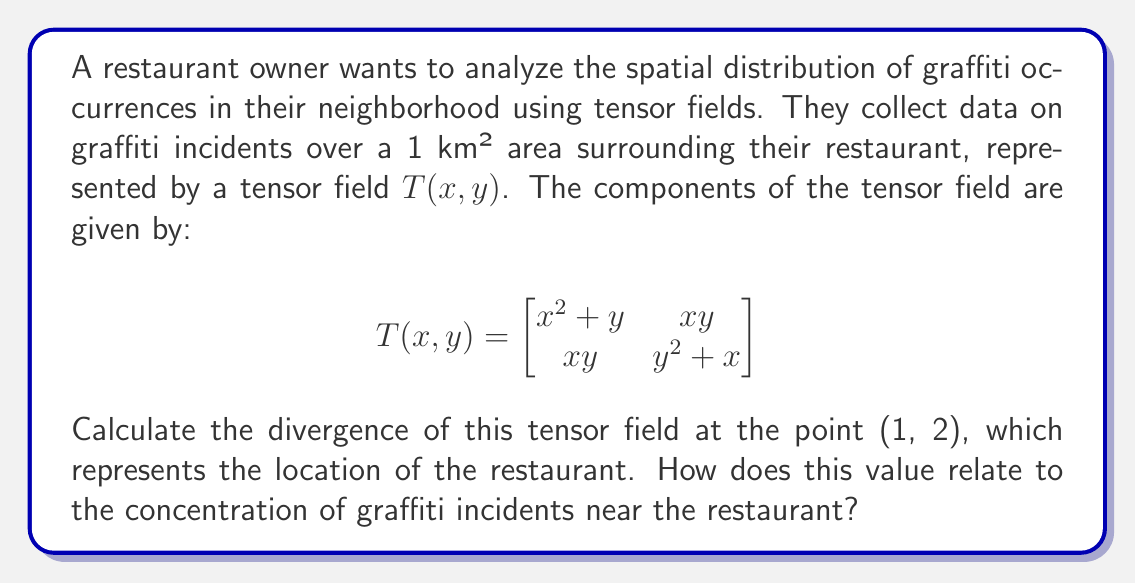Provide a solution to this math problem. To solve this problem, we need to follow these steps:

1) The divergence of a tensor field in 2D is given by:

   $$\text{div}(T) = \frac{\partial T_{11}}{\partial x} + \frac{\partial T_{22}}{\partial y}$$

   where $T_{11}$ and $T_{22}$ are the diagonal components of the tensor.

2) From the given tensor field:
   $T_{11} = x^2 + y$
   $T_{22} = y^2 + x$

3) Calculate the partial derivatives:
   $$\frac{\partial T_{11}}{\partial x} = \frac{\partial (x^2 + y)}{\partial x} = 2x$$
   $$\frac{\partial T_{22}}{\partial y} = \frac{\partial (y^2 + x)}{\partial y} = 2y$$

4) The divergence is the sum of these partial derivatives:
   $$\text{div}(T) = 2x + 2y$$

5) Evaluate at the point (1, 2):
   $$\text{div}(T)|_{(1,2)} = 2(1) + 2(2) = 2 + 4 = 6$$

6) Interpretation: The positive divergence indicates that there is a net outflow of the graffiti field at the restaurant's location. A higher value suggests a higher concentration or source of graffiti incidents near the restaurant.
Answer: 6 